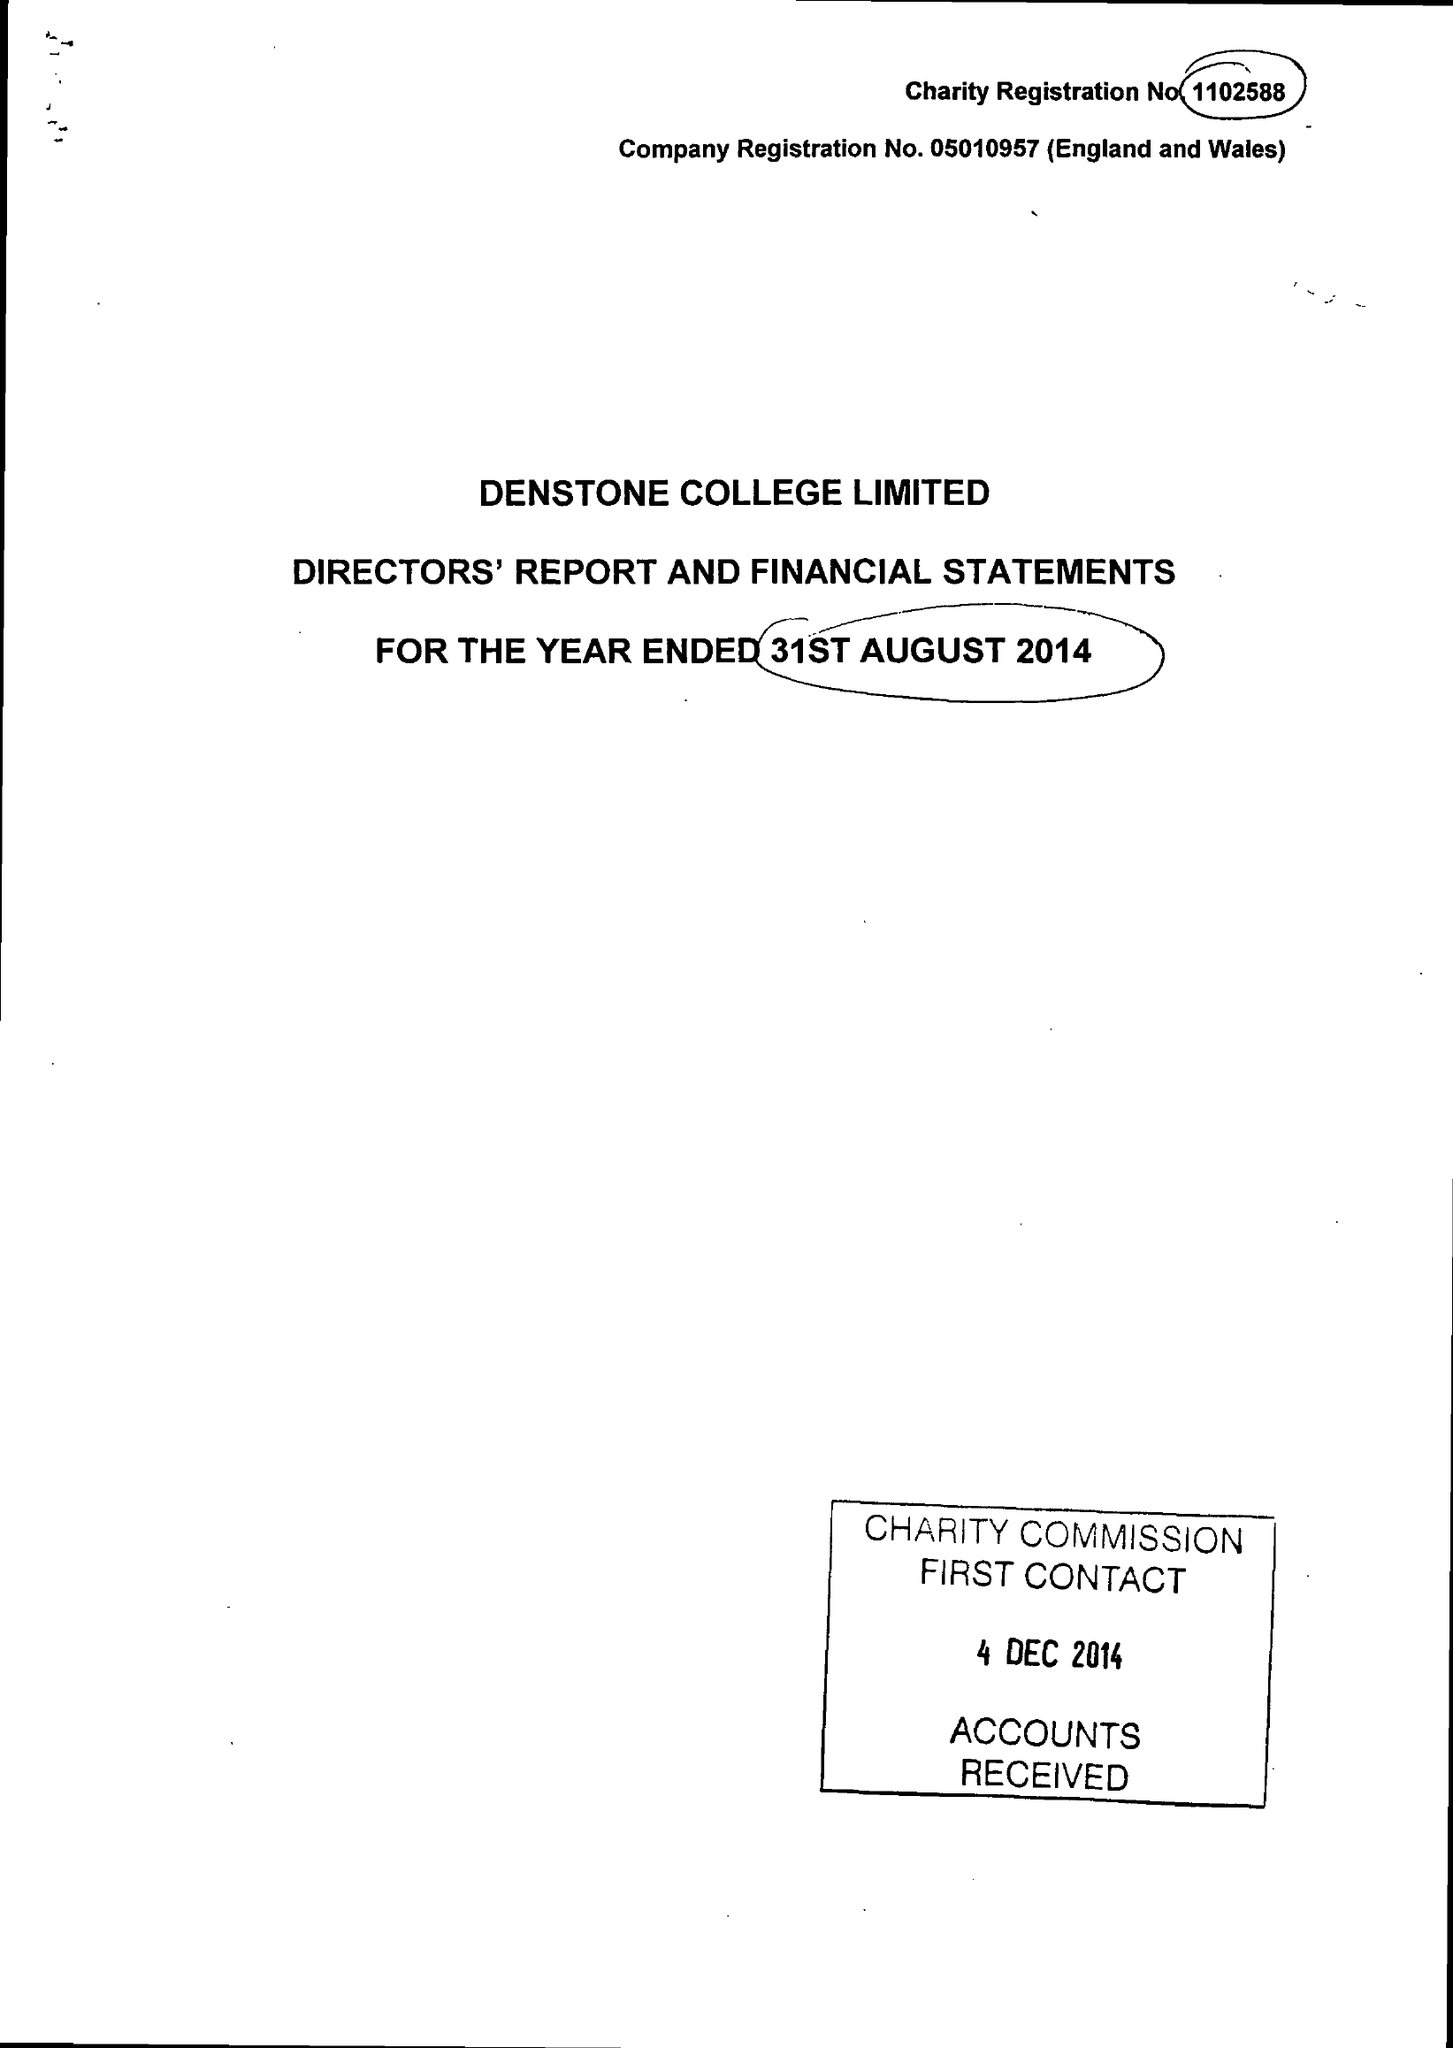What is the value for the address__postcode?
Answer the question using a single word or phrase. ST14 5HN 